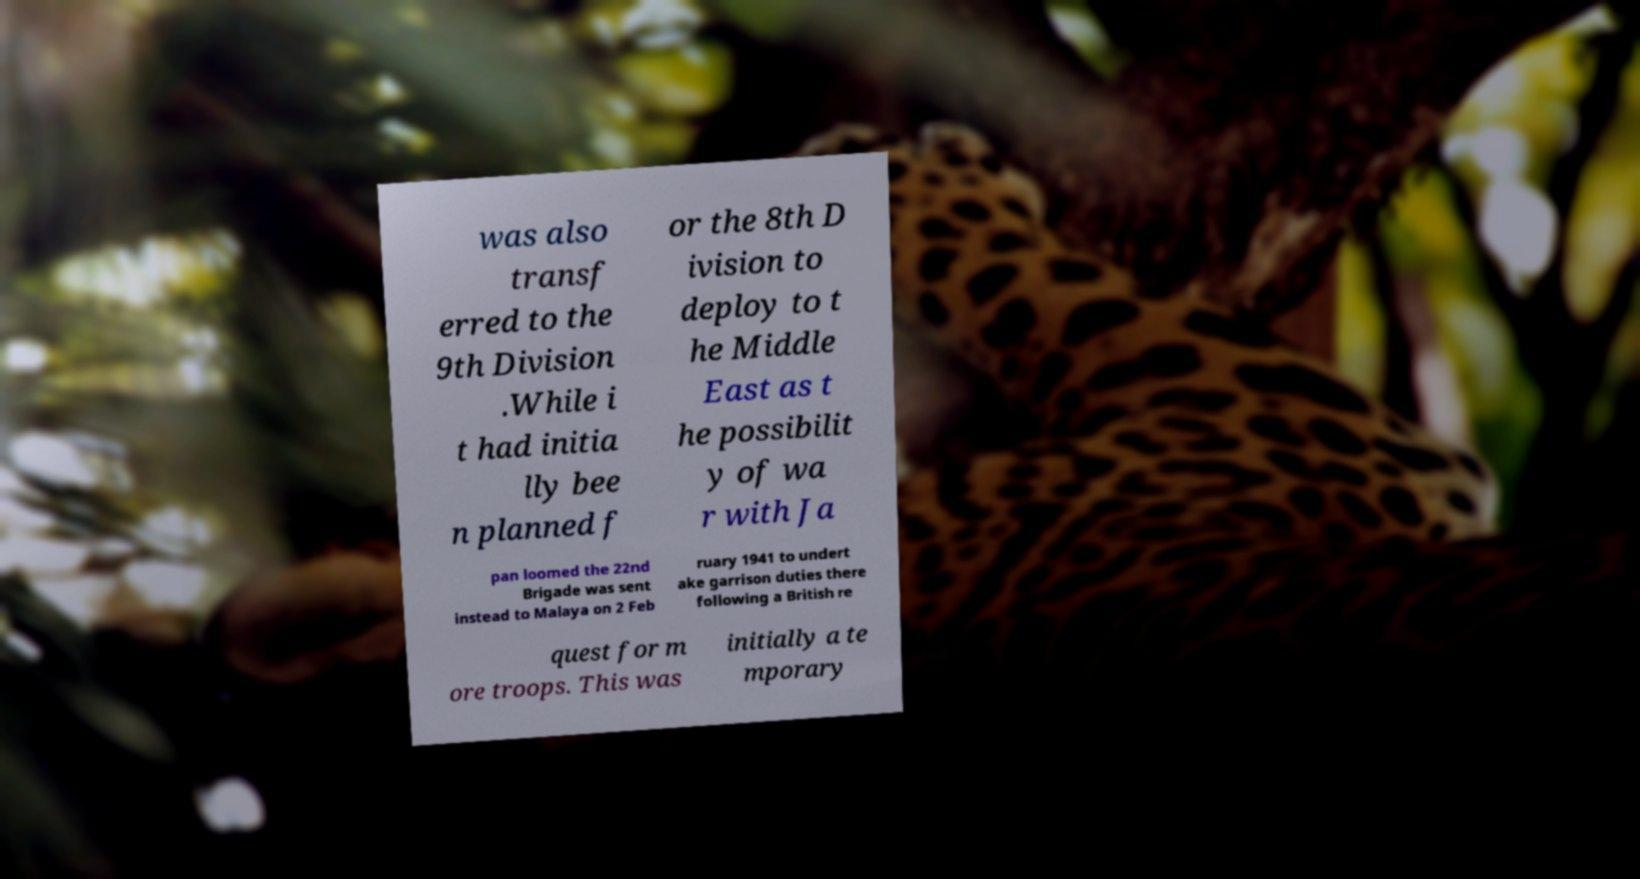Please identify and transcribe the text found in this image. was also transf erred to the 9th Division .While i t had initia lly bee n planned f or the 8th D ivision to deploy to t he Middle East as t he possibilit y of wa r with Ja pan loomed the 22nd Brigade was sent instead to Malaya on 2 Feb ruary 1941 to undert ake garrison duties there following a British re quest for m ore troops. This was initially a te mporary 